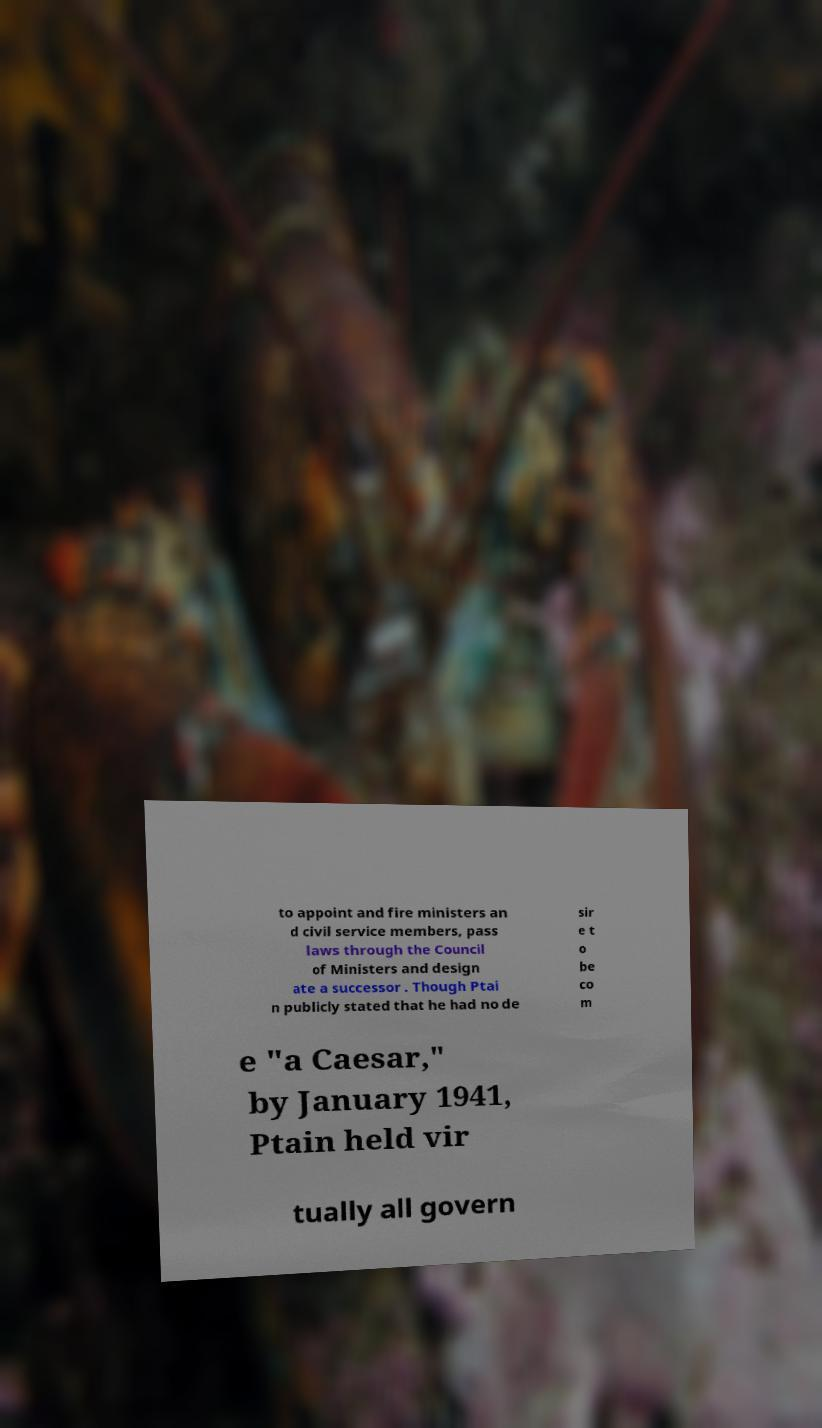What messages or text are displayed in this image? I need them in a readable, typed format. to appoint and fire ministers an d civil service members, pass laws through the Council of Ministers and design ate a successor . Though Ptai n publicly stated that he had no de sir e t o be co m e "a Caesar," by January 1941, Ptain held vir tually all govern 